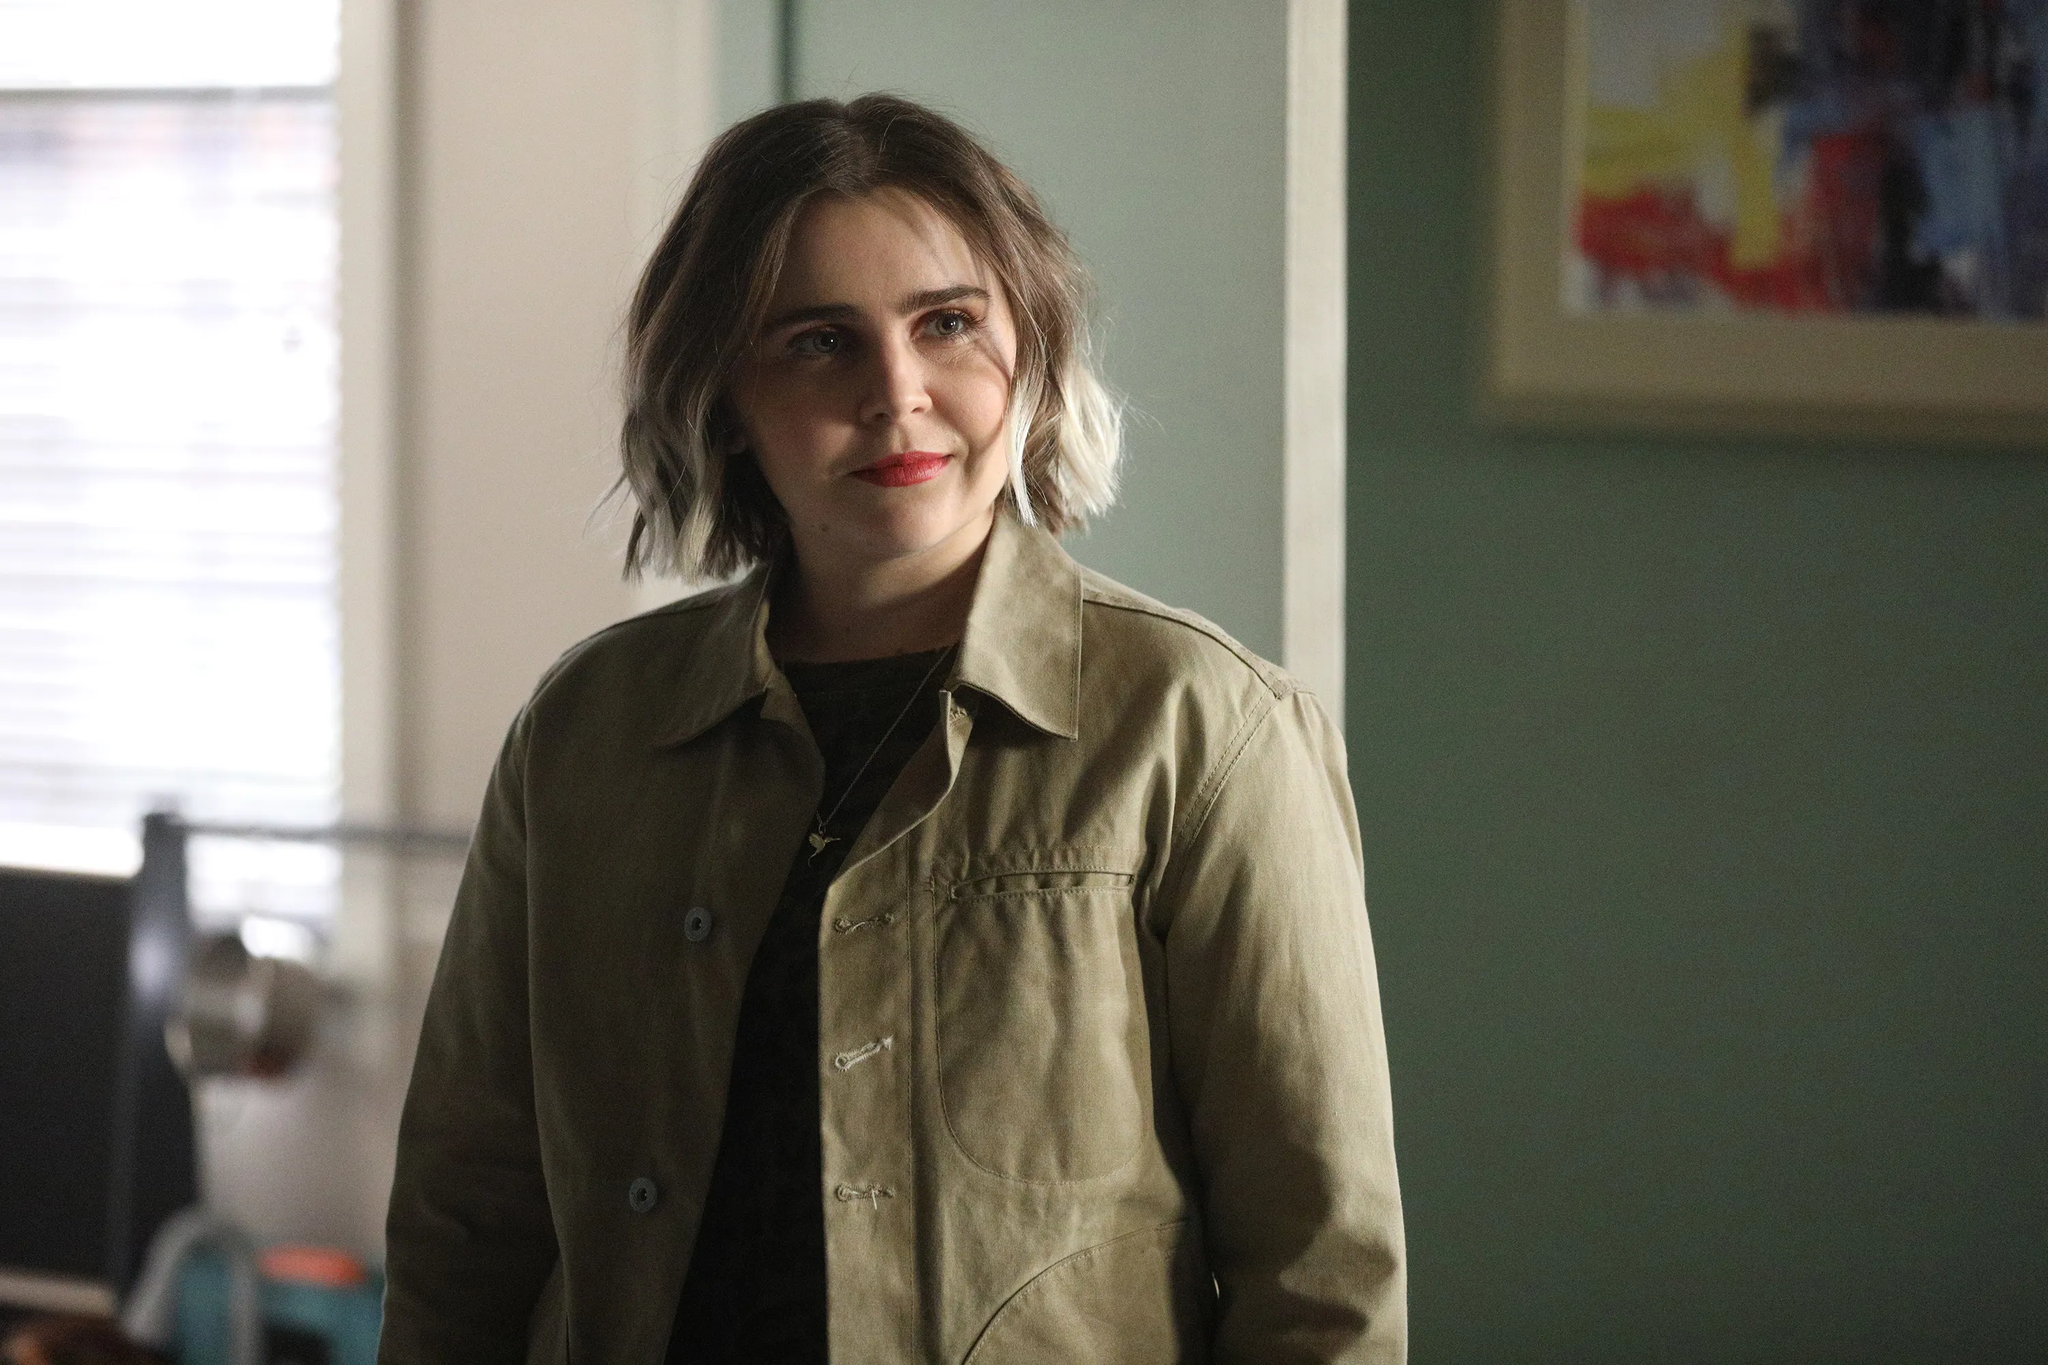What do you see happening in this image? In this image, the central focus is on a woman standing in a room. She appears relaxed and contemplative, leaning slightly with her back against a wall painted in a calm shade of green. Behind her, a colorful abstract painting hangs, adding a splash of creativity and vibrancy to the scene. She is dressed casually in a khaki jacket that matches well with her shoulder-length, slightly wavy blonde hair. Her gaze is directed off to the side, accompanied by a gentle smile that suggests she might be lost in thought or reflecting on something pleasant. The room hints at a cozy and lived-in atmosphere, with softened light filtering in from a window off to the side. 